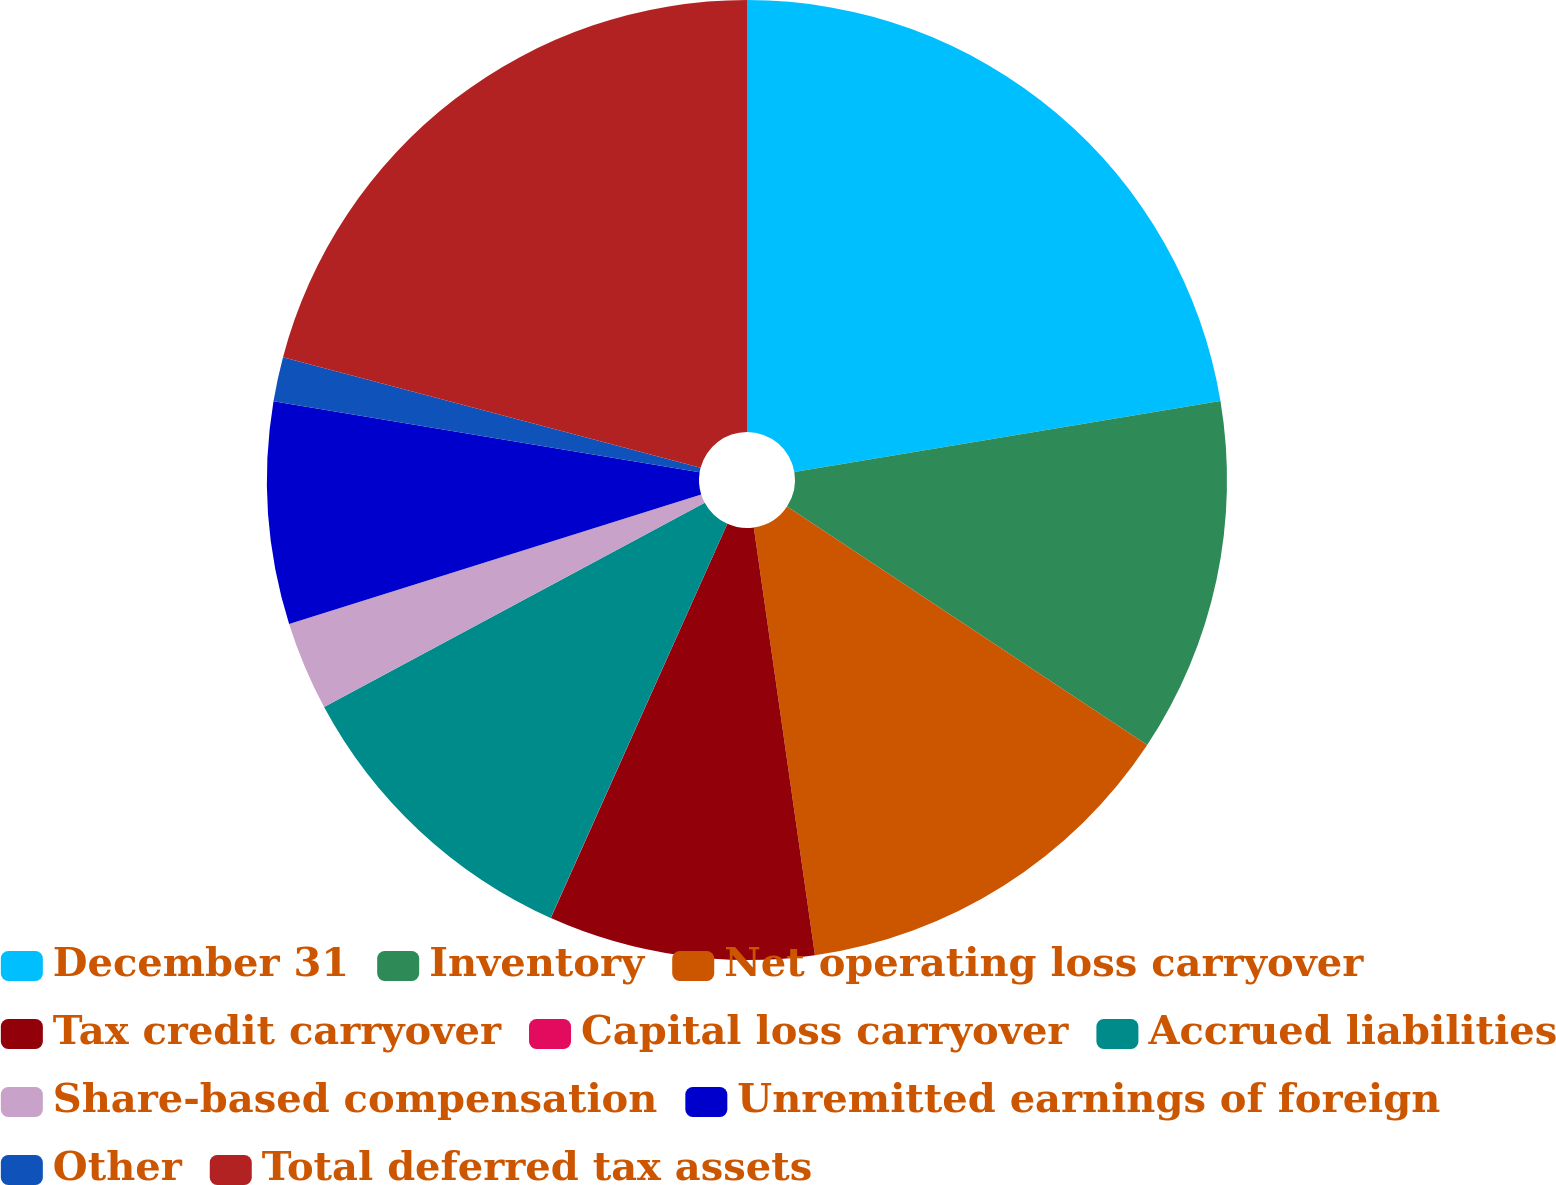Convert chart. <chart><loc_0><loc_0><loc_500><loc_500><pie_chart><fcel>December 31<fcel>Inventory<fcel>Net operating loss carryover<fcel>Tax credit carryover<fcel>Capital loss carryover<fcel>Accrued liabilities<fcel>Share-based compensation<fcel>Unremitted earnings of foreign<fcel>Other<fcel>Total deferred tax assets<nl><fcel>22.37%<fcel>11.94%<fcel>13.43%<fcel>8.96%<fcel>0.01%<fcel>10.45%<fcel>2.99%<fcel>7.47%<fcel>1.5%<fcel>20.88%<nl></chart> 